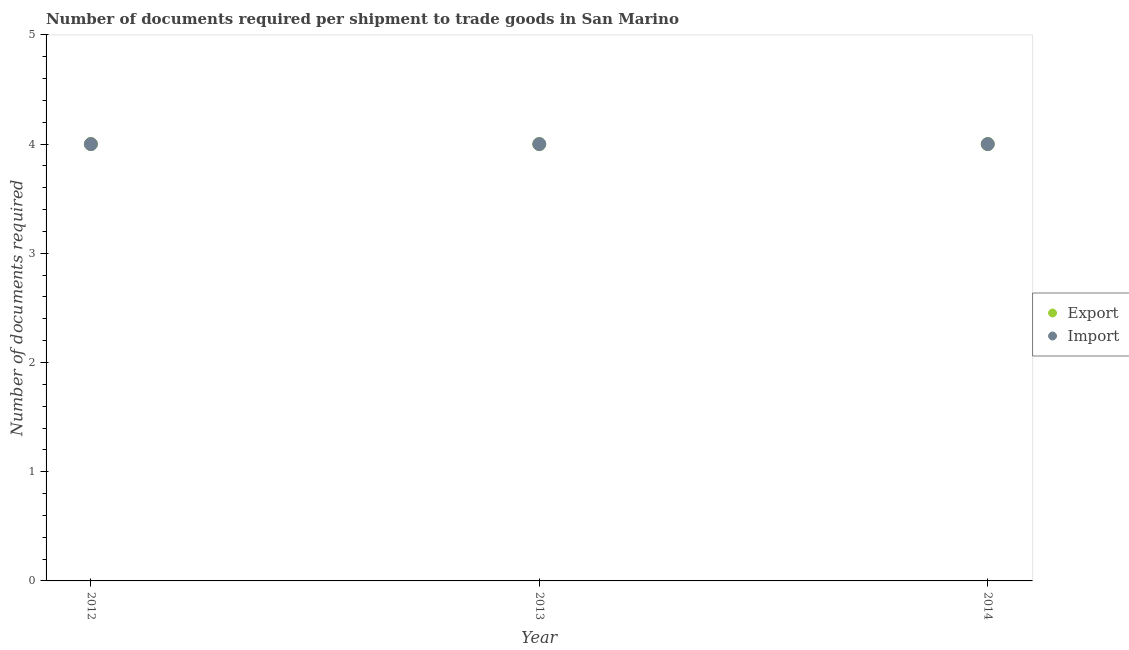How many different coloured dotlines are there?
Offer a terse response. 2. What is the number of documents required to import goods in 2013?
Keep it short and to the point. 4. Across all years, what is the maximum number of documents required to export goods?
Ensure brevity in your answer.  4. Across all years, what is the minimum number of documents required to import goods?
Give a very brief answer. 4. What is the total number of documents required to import goods in the graph?
Offer a very short reply. 12. What is the difference between the number of documents required to import goods in 2012 and that in 2014?
Your answer should be compact. 0. Is the difference between the number of documents required to export goods in 2013 and 2014 greater than the difference between the number of documents required to import goods in 2013 and 2014?
Keep it short and to the point. No. What is the difference between the highest and the lowest number of documents required to import goods?
Make the answer very short. 0. Does the number of documents required to import goods monotonically increase over the years?
Offer a very short reply. No. Is the number of documents required to import goods strictly greater than the number of documents required to export goods over the years?
Make the answer very short. No. Is the number of documents required to import goods strictly less than the number of documents required to export goods over the years?
Offer a very short reply. No. Where does the legend appear in the graph?
Offer a terse response. Center right. How are the legend labels stacked?
Ensure brevity in your answer.  Vertical. What is the title of the graph?
Ensure brevity in your answer.  Number of documents required per shipment to trade goods in San Marino. Does "Health Care" appear as one of the legend labels in the graph?
Your answer should be very brief. No. What is the label or title of the X-axis?
Offer a terse response. Year. What is the label or title of the Y-axis?
Your answer should be very brief. Number of documents required. What is the Number of documents required of Export in 2012?
Your answer should be very brief. 4. What is the Number of documents required in Import in 2012?
Make the answer very short. 4. What is the Number of documents required in Export in 2013?
Keep it short and to the point. 4. Across all years, what is the minimum Number of documents required of Export?
Your response must be concise. 4. Across all years, what is the minimum Number of documents required in Import?
Your response must be concise. 4. What is the total Number of documents required in Export in the graph?
Your answer should be very brief. 12. What is the total Number of documents required in Import in the graph?
Keep it short and to the point. 12. What is the difference between the Number of documents required in Export in 2012 and that in 2014?
Your response must be concise. 0. What is the difference between the Number of documents required of Import in 2013 and that in 2014?
Provide a succinct answer. 0. What is the difference between the Number of documents required of Export in 2012 and the Number of documents required of Import in 2014?
Give a very brief answer. 0. What is the difference between the Number of documents required of Export in 2013 and the Number of documents required of Import in 2014?
Offer a very short reply. 0. In the year 2012, what is the difference between the Number of documents required in Export and Number of documents required in Import?
Make the answer very short. 0. In the year 2013, what is the difference between the Number of documents required of Export and Number of documents required of Import?
Provide a succinct answer. 0. What is the ratio of the Number of documents required in Import in 2012 to that in 2014?
Ensure brevity in your answer.  1. What is the ratio of the Number of documents required of Import in 2013 to that in 2014?
Your response must be concise. 1. What is the difference between the highest and the second highest Number of documents required in Export?
Offer a terse response. 0. What is the difference between the highest and the second highest Number of documents required of Import?
Ensure brevity in your answer.  0. What is the difference between the highest and the lowest Number of documents required in Import?
Your answer should be very brief. 0. 